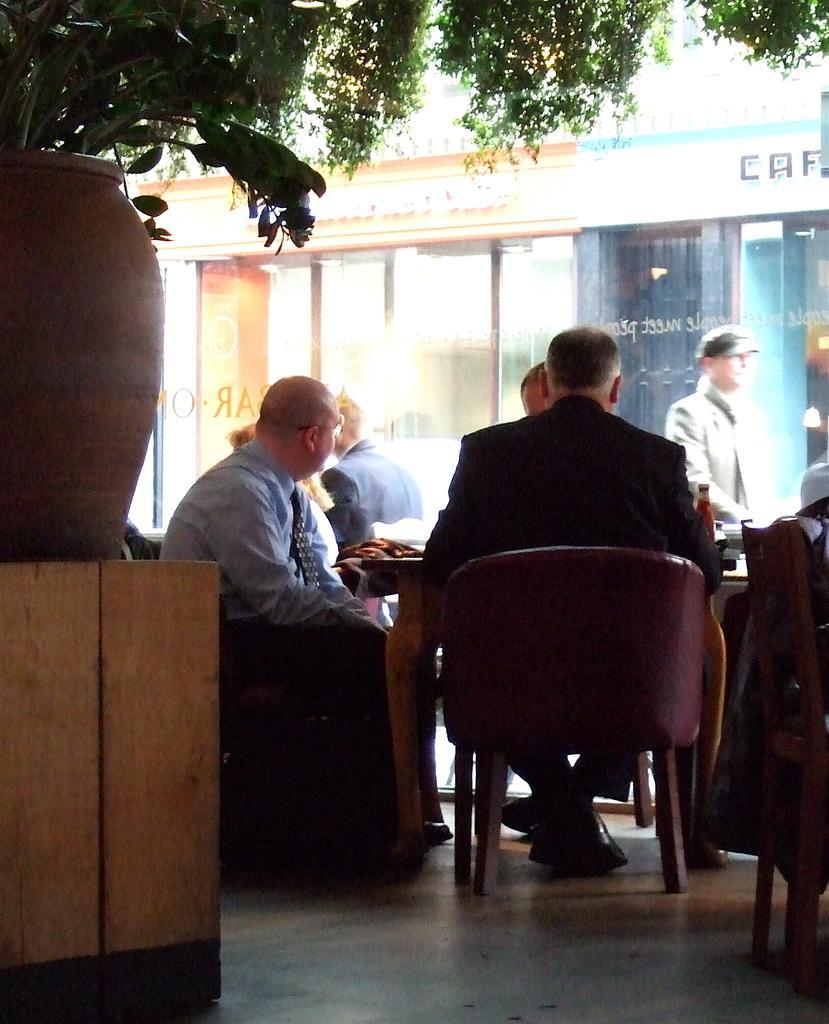How would you summarize this image in a sentence or two? There are group of people sitting on the chairs in front of the table. I think this is a bottle placed on the table. At left corner of the image I can see a big flower pot. This is a small plant planted in the flower pot. At background I can see a man walking. At top of the image I can see tree leaves. This is a building With the name board. 